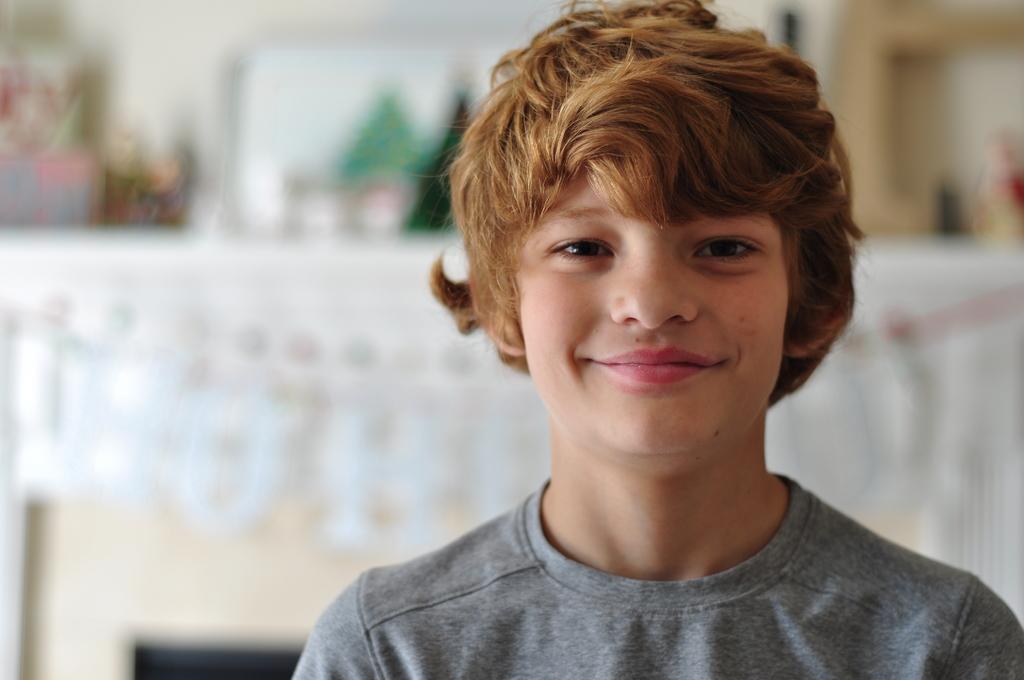Please provide a concise description of this image. In this picture we can see a boy in the t shirt and the boy is smiling. Behind the boy, there are some blurred objects. 